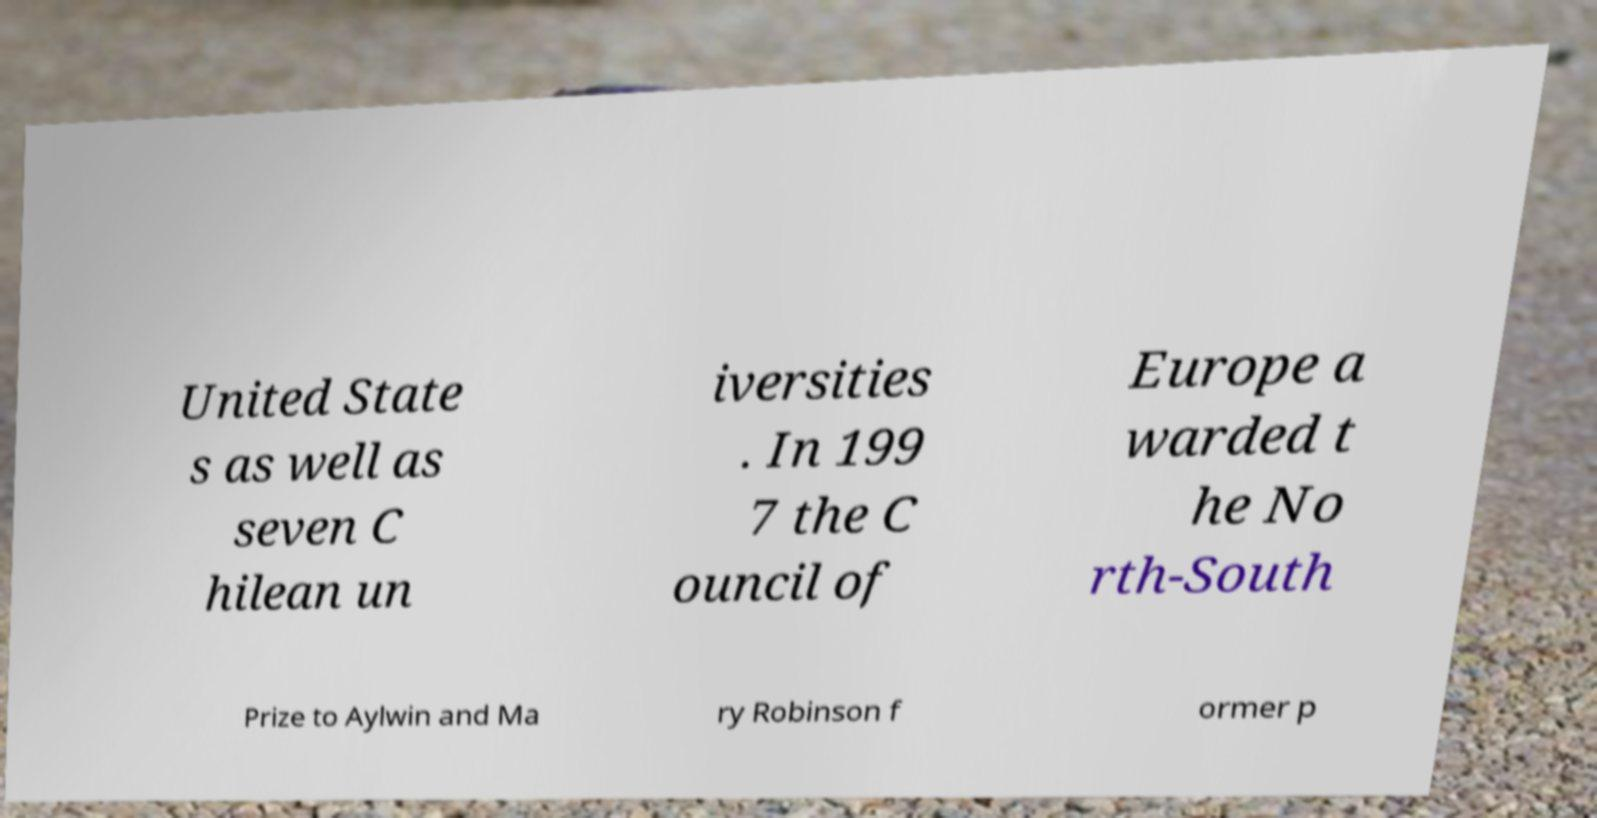Could you extract and type out the text from this image? United State s as well as seven C hilean un iversities . In 199 7 the C ouncil of Europe a warded t he No rth-South Prize to Aylwin and Ma ry Robinson f ormer p 